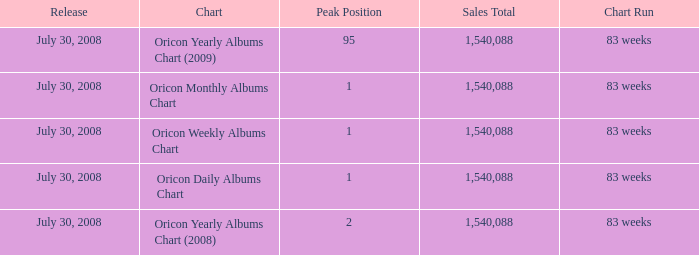Which Chart has a Peak Position of 1? Oricon Daily Albums Chart, Oricon Weekly Albums Chart, Oricon Monthly Albums Chart. 